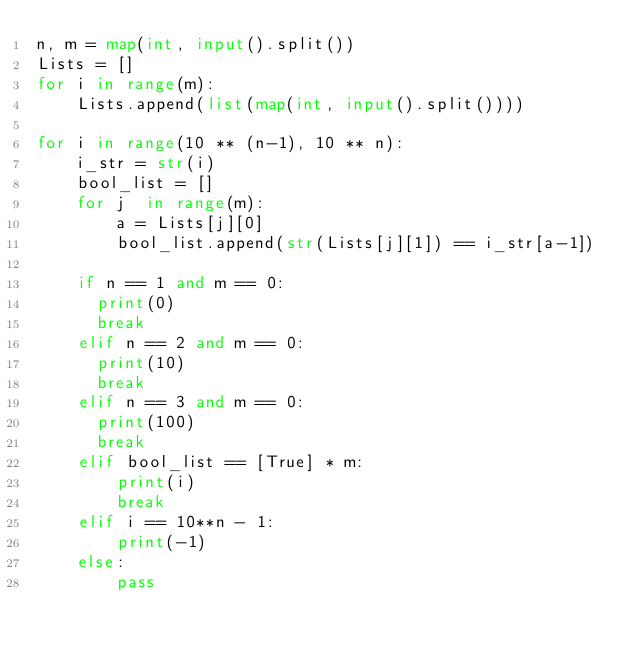<code> <loc_0><loc_0><loc_500><loc_500><_Python_>n, m = map(int, input().split())
Lists = []
for i in range(m):
    Lists.append(list(map(int, input().split())))

for i in range(10 ** (n-1), 10 ** n):
    i_str = str(i)
    bool_list = []
    for j  in range(m):
        a = Lists[j][0]
        bool_list.append(str(Lists[j][1]) == i_str[a-1])
    
    if n == 1 and m == 0:
      print(0)
      break
    elif n == 2 and m == 0:
      print(10)
      break
    elif n == 3 and m == 0:
      print(100)
      break
    elif bool_list == [True] * m:
        print(i)
        break
    elif i == 10**n - 1:
        print(-1)
    else:
        pass</code> 